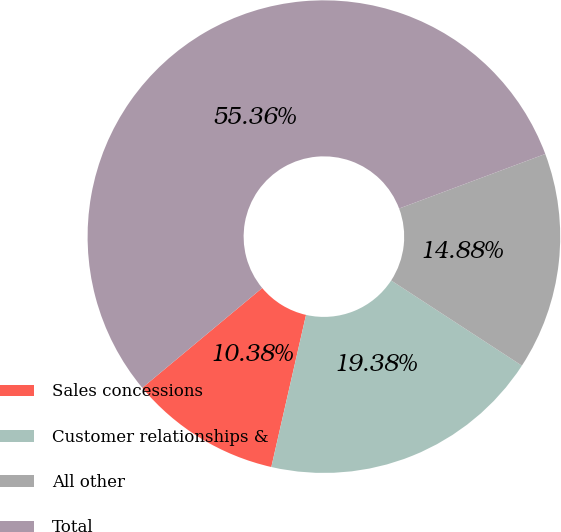Convert chart. <chart><loc_0><loc_0><loc_500><loc_500><pie_chart><fcel>Sales concessions<fcel>Customer relationships &<fcel>All other<fcel>Total<nl><fcel>10.38%<fcel>19.38%<fcel>14.88%<fcel>55.36%<nl></chart> 